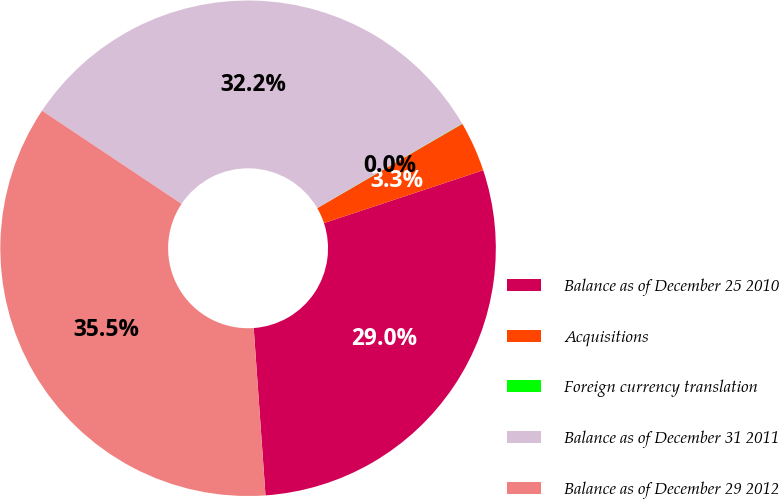Convert chart. <chart><loc_0><loc_0><loc_500><loc_500><pie_chart><fcel>Balance as of December 25 2010<fcel>Acquisitions<fcel>Foreign currency translation<fcel>Balance as of December 31 2011<fcel>Balance as of December 29 2012<nl><fcel>28.98%<fcel>3.27%<fcel>0.02%<fcel>32.24%<fcel>35.49%<nl></chart> 